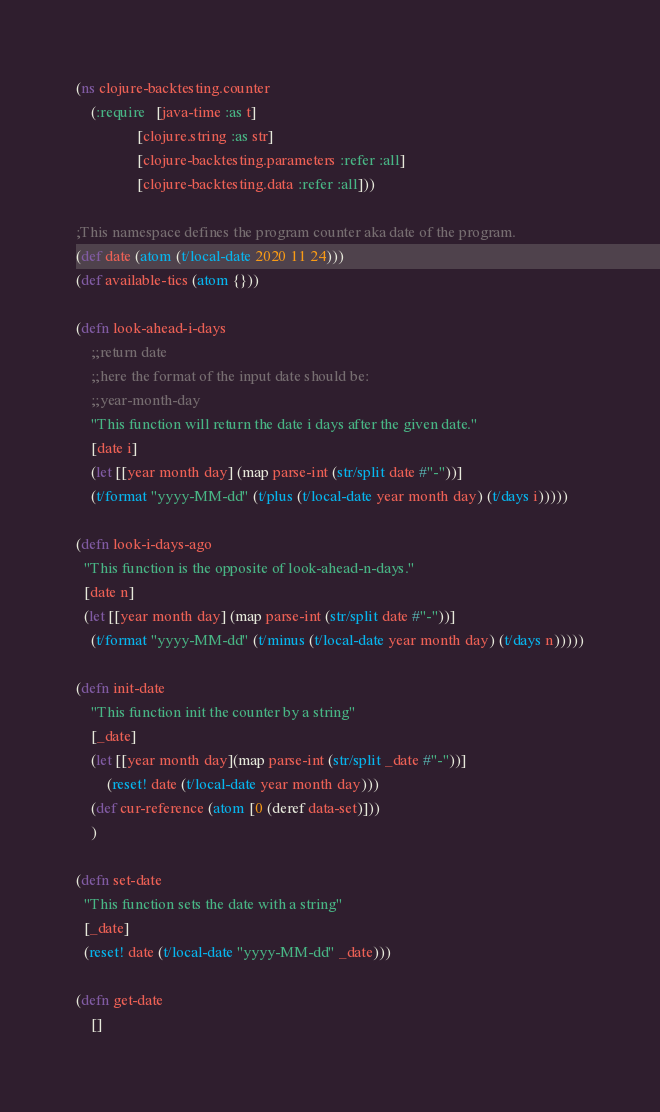<code> <loc_0><loc_0><loc_500><loc_500><_Clojure_>(ns clojure-backtesting.counter
    (:require   [java-time :as t]
                [clojure.string :as str]
                [clojure-backtesting.parameters :refer :all]
                [clojure-backtesting.data :refer :all]))

;This namespace defines the program counter aka date of the program. 
(def date (atom (t/local-date 2020 11 24)))
(def available-tics (atom {}))

(defn look-ahead-i-days
	;;return date
	;;here the format of the input date should be:
	;;year-month-day
 	"This function will return the date i days after the given date."
	[date i]
	(let [[year month day] (map parse-int (str/split date #"-"))]
    (t/format "yyyy-MM-dd" (t/plus (t/local-date year month day) (t/days i)))))

(defn look-i-days-ago
  "This function is the opposite of look-ahead-n-days."
  [date n]
  (let [[year month day] (map parse-int (str/split date #"-"))]
    (t/format "yyyy-MM-dd" (t/minus (t/local-date year month day) (t/days n)))))

(defn init-date
    "This function init the counter by a string"
    [_date]
    (let [[year month day](map parse-int (str/split _date #"-"))]
        (reset! date (t/local-date year month day)))
    (def cur-reference (atom [0 (deref data-set)]))
    )

(defn set-date
  "This function sets the date with a string"
  [_date]
  (reset! date (t/local-date "yyyy-MM-dd" _date)))

(defn get-date
    []</code> 